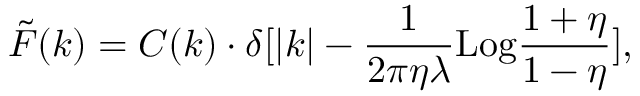<formula> <loc_0><loc_0><loc_500><loc_500>\tilde { F } ( k ) = C ( k ) \cdot \delta [ | k | - { \frac { 1 } { 2 \pi \eta \lambda } } L o g { \frac { 1 + \eta } { 1 - \eta } } ] ,</formula> 